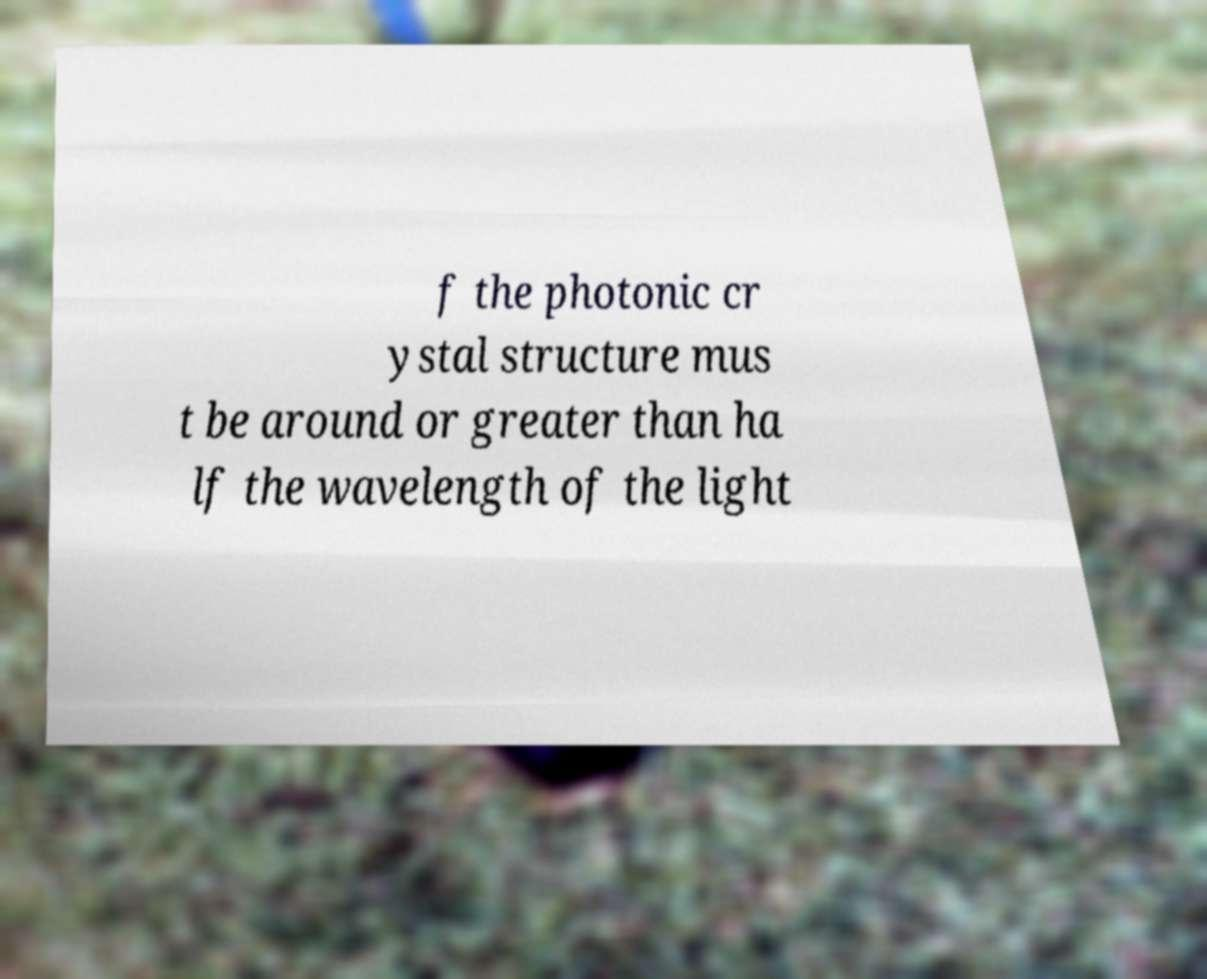What messages or text are displayed in this image? I need them in a readable, typed format. f the photonic cr ystal structure mus t be around or greater than ha lf the wavelength of the light 